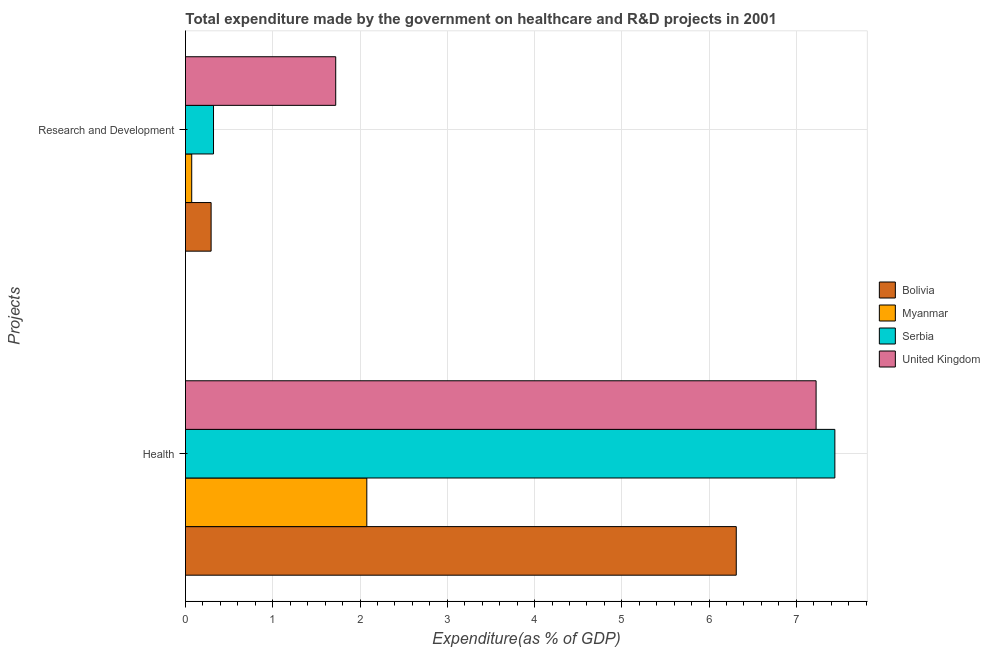Are the number of bars on each tick of the Y-axis equal?
Your answer should be compact. Yes. What is the label of the 2nd group of bars from the top?
Offer a very short reply. Health. What is the expenditure in r&d in United Kingdom?
Offer a very short reply. 1.72. Across all countries, what is the maximum expenditure in healthcare?
Your answer should be compact. 7.44. Across all countries, what is the minimum expenditure in healthcare?
Your answer should be compact. 2.08. In which country was the expenditure in r&d maximum?
Your answer should be very brief. United Kingdom. In which country was the expenditure in healthcare minimum?
Provide a short and direct response. Myanmar. What is the total expenditure in r&d in the graph?
Your answer should be very brief. 2.41. What is the difference between the expenditure in r&d in Myanmar and that in Bolivia?
Offer a terse response. -0.22. What is the difference between the expenditure in healthcare in Myanmar and the expenditure in r&d in Bolivia?
Your answer should be compact. 1.78. What is the average expenditure in healthcare per country?
Your answer should be very brief. 5.76. What is the difference between the expenditure in healthcare and expenditure in r&d in Bolivia?
Keep it short and to the point. 6.02. In how many countries, is the expenditure in healthcare greater than 1.4 %?
Provide a short and direct response. 4. What is the ratio of the expenditure in r&d in Bolivia to that in Serbia?
Your response must be concise. 0.91. Is the expenditure in r&d in Serbia less than that in United Kingdom?
Your answer should be very brief. Yes. In how many countries, is the expenditure in healthcare greater than the average expenditure in healthcare taken over all countries?
Provide a succinct answer. 3. What does the 4th bar from the bottom in Health represents?
Provide a succinct answer. United Kingdom. Are all the bars in the graph horizontal?
Offer a very short reply. Yes. How many countries are there in the graph?
Offer a very short reply. 4. Are the values on the major ticks of X-axis written in scientific E-notation?
Your answer should be compact. No. Does the graph contain grids?
Keep it short and to the point. Yes. How many legend labels are there?
Keep it short and to the point. 4. How are the legend labels stacked?
Offer a very short reply. Vertical. What is the title of the graph?
Provide a short and direct response. Total expenditure made by the government on healthcare and R&D projects in 2001. Does "Indonesia" appear as one of the legend labels in the graph?
Ensure brevity in your answer.  No. What is the label or title of the X-axis?
Your response must be concise. Expenditure(as % of GDP). What is the label or title of the Y-axis?
Offer a terse response. Projects. What is the Expenditure(as % of GDP) in Bolivia in Health?
Keep it short and to the point. 6.31. What is the Expenditure(as % of GDP) in Myanmar in Health?
Make the answer very short. 2.08. What is the Expenditure(as % of GDP) in Serbia in Health?
Your answer should be compact. 7.44. What is the Expenditure(as % of GDP) in United Kingdom in Health?
Your answer should be compact. 7.23. What is the Expenditure(as % of GDP) of Bolivia in Research and Development?
Your answer should be very brief. 0.29. What is the Expenditure(as % of GDP) of Myanmar in Research and Development?
Your response must be concise. 0.07. What is the Expenditure(as % of GDP) of Serbia in Research and Development?
Provide a succinct answer. 0.32. What is the Expenditure(as % of GDP) of United Kingdom in Research and Development?
Your answer should be very brief. 1.72. Across all Projects, what is the maximum Expenditure(as % of GDP) of Bolivia?
Offer a very short reply. 6.31. Across all Projects, what is the maximum Expenditure(as % of GDP) of Myanmar?
Provide a succinct answer. 2.08. Across all Projects, what is the maximum Expenditure(as % of GDP) in Serbia?
Offer a very short reply. 7.44. Across all Projects, what is the maximum Expenditure(as % of GDP) of United Kingdom?
Make the answer very short. 7.23. Across all Projects, what is the minimum Expenditure(as % of GDP) of Bolivia?
Keep it short and to the point. 0.29. Across all Projects, what is the minimum Expenditure(as % of GDP) in Myanmar?
Your answer should be very brief. 0.07. Across all Projects, what is the minimum Expenditure(as % of GDP) of Serbia?
Your answer should be very brief. 0.32. Across all Projects, what is the minimum Expenditure(as % of GDP) in United Kingdom?
Offer a terse response. 1.72. What is the total Expenditure(as % of GDP) of Bolivia in the graph?
Offer a very short reply. 6.61. What is the total Expenditure(as % of GDP) of Myanmar in the graph?
Keep it short and to the point. 2.15. What is the total Expenditure(as % of GDP) of Serbia in the graph?
Your answer should be compact. 7.76. What is the total Expenditure(as % of GDP) of United Kingdom in the graph?
Provide a succinct answer. 8.95. What is the difference between the Expenditure(as % of GDP) of Bolivia in Health and that in Research and Development?
Give a very brief answer. 6.02. What is the difference between the Expenditure(as % of GDP) in Myanmar in Health and that in Research and Development?
Offer a very short reply. 2.01. What is the difference between the Expenditure(as % of GDP) of Serbia in Health and that in Research and Development?
Your answer should be very brief. 7.12. What is the difference between the Expenditure(as % of GDP) in United Kingdom in Health and that in Research and Development?
Provide a short and direct response. 5.5. What is the difference between the Expenditure(as % of GDP) in Bolivia in Health and the Expenditure(as % of GDP) in Myanmar in Research and Development?
Provide a short and direct response. 6.24. What is the difference between the Expenditure(as % of GDP) of Bolivia in Health and the Expenditure(as % of GDP) of Serbia in Research and Development?
Your response must be concise. 5.99. What is the difference between the Expenditure(as % of GDP) of Bolivia in Health and the Expenditure(as % of GDP) of United Kingdom in Research and Development?
Your response must be concise. 4.59. What is the difference between the Expenditure(as % of GDP) in Myanmar in Health and the Expenditure(as % of GDP) in Serbia in Research and Development?
Offer a terse response. 1.76. What is the difference between the Expenditure(as % of GDP) in Myanmar in Health and the Expenditure(as % of GDP) in United Kingdom in Research and Development?
Your response must be concise. 0.36. What is the difference between the Expenditure(as % of GDP) in Serbia in Health and the Expenditure(as % of GDP) in United Kingdom in Research and Development?
Make the answer very short. 5.72. What is the average Expenditure(as % of GDP) in Bolivia per Projects?
Provide a succinct answer. 3.3. What is the average Expenditure(as % of GDP) in Myanmar per Projects?
Provide a short and direct response. 1.07. What is the average Expenditure(as % of GDP) of Serbia per Projects?
Offer a very short reply. 3.88. What is the average Expenditure(as % of GDP) in United Kingdom per Projects?
Give a very brief answer. 4.47. What is the difference between the Expenditure(as % of GDP) of Bolivia and Expenditure(as % of GDP) of Myanmar in Health?
Your response must be concise. 4.23. What is the difference between the Expenditure(as % of GDP) of Bolivia and Expenditure(as % of GDP) of Serbia in Health?
Provide a short and direct response. -1.13. What is the difference between the Expenditure(as % of GDP) of Bolivia and Expenditure(as % of GDP) of United Kingdom in Health?
Offer a terse response. -0.91. What is the difference between the Expenditure(as % of GDP) in Myanmar and Expenditure(as % of GDP) in Serbia in Health?
Ensure brevity in your answer.  -5.36. What is the difference between the Expenditure(as % of GDP) in Myanmar and Expenditure(as % of GDP) in United Kingdom in Health?
Give a very brief answer. -5.15. What is the difference between the Expenditure(as % of GDP) in Serbia and Expenditure(as % of GDP) in United Kingdom in Health?
Your answer should be very brief. 0.22. What is the difference between the Expenditure(as % of GDP) of Bolivia and Expenditure(as % of GDP) of Myanmar in Research and Development?
Provide a short and direct response. 0.22. What is the difference between the Expenditure(as % of GDP) in Bolivia and Expenditure(as % of GDP) in Serbia in Research and Development?
Provide a short and direct response. -0.03. What is the difference between the Expenditure(as % of GDP) of Bolivia and Expenditure(as % of GDP) of United Kingdom in Research and Development?
Make the answer very short. -1.43. What is the difference between the Expenditure(as % of GDP) of Myanmar and Expenditure(as % of GDP) of Serbia in Research and Development?
Your answer should be compact. -0.25. What is the difference between the Expenditure(as % of GDP) of Myanmar and Expenditure(as % of GDP) of United Kingdom in Research and Development?
Offer a terse response. -1.65. What is the difference between the Expenditure(as % of GDP) of Serbia and Expenditure(as % of GDP) of United Kingdom in Research and Development?
Ensure brevity in your answer.  -1.4. What is the ratio of the Expenditure(as % of GDP) in Bolivia in Health to that in Research and Development?
Offer a terse response. 21.5. What is the ratio of the Expenditure(as % of GDP) of Myanmar in Health to that in Research and Development?
Offer a very short reply. 29.08. What is the ratio of the Expenditure(as % of GDP) of Serbia in Health to that in Research and Development?
Ensure brevity in your answer.  23.17. What is the ratio of the Expenditure(as % of GDP) of United Kingdom in Health to that in Research and Development?
Provide a succinct answer. 4.2. What is the difference between the highest and the second highest Expenditure(as % of GDP) of Bolivia?
Your answer should be compact. 6.02. What is the difference between the highest and the second highest Expenditure(as % of GDP) in Myanmar?
Give a very brief answer. 2.01. What is the difference between the highest and the second highest Expenditure(as % of GDP) in Serbia?
Keep it short and to the point. 7.12. What is the difference between the highest and the second highest Expenditure(as % of GDP) in United Kingdom?
Provide a short and direct response. 5.5. What is the difference between the highest and the lowest Expenditure(as % of GDP) of Bolivia?
Make the answer very short. 6.02. What is the difference between the highest and the lowest Expenditure(as % of GDP) in Myanmar?
Make the answer very short. 2.01. What is the difference between the highest and the lowest Expenditure(as % of GDP) in Serbia?
Provide a short and direct response. 7.12. What is the difference between the highest and the lowest Expenditure(as % of GDP) in United Kingdom?
Provide a succinct answer. 5.5. 